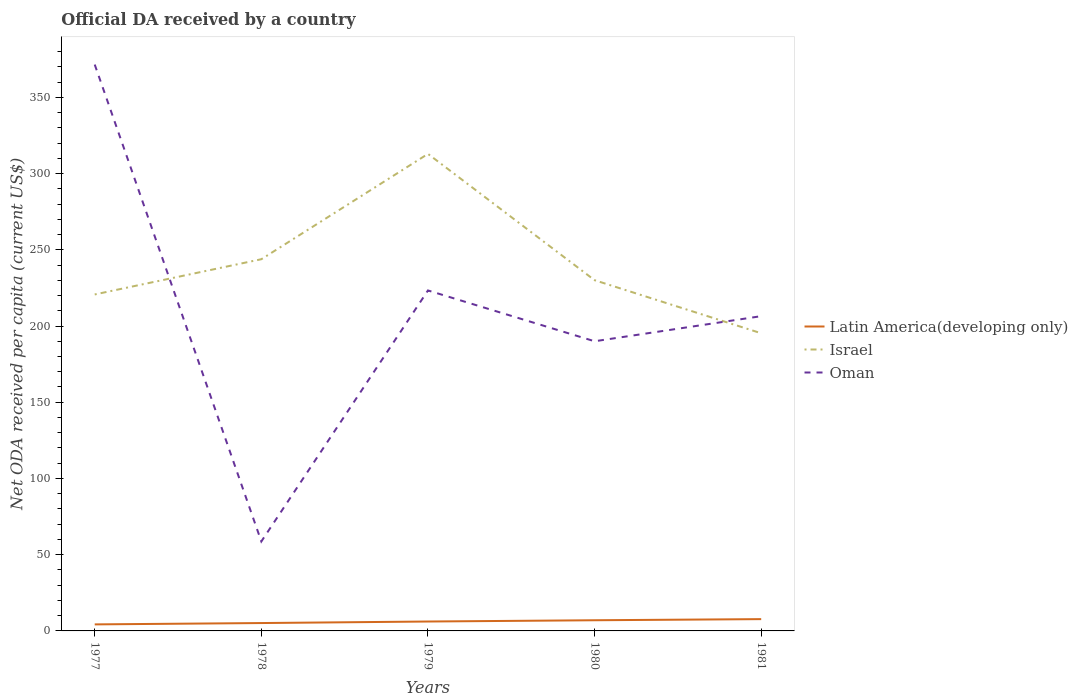How many different coloured lines are there?
Ensure brevity in your answer.  3. Across all years, what is the maximum ODA received in in Latin America(developing only)?
Provide a short and direct response. 4.28. In which year was the ODA received in in Latin America(developing only) maximum?
Your answer should be compact. 1977. What is the total ODA received in in Israel in the graph?
Keep it short and to the point. 13.76. What is the difference between the highest and the second highest ODA received in in Israel?
Provide a succinct answer. 117.66. What is the difference between the highest and the lowest ODA received in in Oman?
Make the answer very short. 2. Is the ODA received in in Oman strictly greater than the ODA received in in Latin America(developing only) over the years?
Make the answer very short. No. How many lines are there?
Make the answer very short. 3. How many years are there in the graph?
Offer a very short reply. 5. Does the graph contain any zero values?
Give a very brief answer. No. How many legend labels are there?
Keep it short and to the point. 3. What is the title of the graph?
Provide a succinct answer. Official DA received by a country. What is the label or title of the Y-axis?
Provide a short and direct response. Net ODA received per capita (current US$). What is the Net ODA received per capita (current US$) of Latin America(developing only) in 1977?
Offer a terse response. 4.28. What is the Net ODA received per capita (current US$) in Israel in 1977?
Provide a succinct answer. 220.7. What is the Net ODA received per capita (current US$) in Oman in 1977?
Provide a short and direct response. 371.49. What is the Net ODA received per capita (current US$) in Latin America(developing only) in 1978?
Offer a very short reply. 5.17. What is the Net ODA received per capita (current US$) in Israel in 1978?
Ensure brevity in your answer.  243.81. What is the Net ODA received per capita (current US$) in Oman in 1978?
Provide a short and direct response. 58.69. What is the Net ODA received per capita (current US$) in Latin America(developing only) in 1979?
Keep it short and to the point. 6.17. What is the Net ODA received per capita (current US$) of Israel in 1979?
Your response must be concise. 312.91. What is the Net ODA received per capita (current US$) of Oman in 1979?
Make the answer very short. 223.33. What is the Net ODA received per capita (current US$) in Latin America(developing only) in 1980?
Offer a terse response. 7. What is the Net ODA received per capita (current US$) in Israel in 1980?
Your answer should be very brief. 230.06. What is the Net ODA received per capita (current US$) of Oman in 1980?
Provide a succinct answer. 190. What is the Net ODA received per capita (current US$) in Latin America(developing only) in 1981?
Offer a very short reply. 7.73. What is the Net ODA received per capita (current US$) in Israel in 1981?
Your response must be concise. 195.25. What is the Net ODA received per capita (current US$) in Oman in 1981?
Your response must be concise. 206.46. Across all years, what is the maximum Net ODA received per capita (current US$) of Latin America(developing only)?
Give a very brief answer. 7.73. Across all years, what is the maximum Net ODA received per capita (current US$) in Israel?
Provide a succinct answer. 312.91. Across all years, what is the maximum Net ODA received per capita (current US$) of Oman?
Keep it short and to the point. 371.49. Across all years, what is the minimum Net ODA received per capita (current US$) in Latin America(developing only)?
Keep it short and to the point. 4.28. Across all years, what is the minimum Net ODA received per capita (current US$) in Israel?
Offer a very short reply. 195.25. Across all years, what is the minimum Net ODA received per capita (current US$) of Oman?
Offer a very short reply. 58.69. What is the total Net ODA received per capita (current US$) in Latin America(developing only) in the graph?
Give a very brief answer. 30.35. What is the total Net ODA received per capita (current US$) in Israel in the graph?
Offer a terse response. 1202.73. What is the total Net ODA received per capita (current US$) of Oman in the graph?
Offer a terse response. 1049.98. What is the difference between the Net ODA received per capita (current US$) in Latin America(developing only) in 1977 and that in 1978?
Give a very brief answer. -0.89. What is the difference between the Net ODA received per capita (current US$) of Israel in 1977 and that in 1978?
Give a very brief answer. -23.11. What is the difference between the Net ODA received per capita (current US$) in Oman in 1977 and that in 1978?
Offer a terse response. 312.8. What is the difference between the Net ODA received per capita (current US$) in Latin America(developing only) in 1977 and that in 1979?
Provide a succinct answer. -1.89. What is the difference between the Net ODA received per capita (current US$) in Israel in 1977 and that in 1979?
Give a very brief answer. -92.21. What is the difference between the Net ODA received per capita (current US$) in Oman in 1977 and that in 1979?
Keep it short and to the point. 148.17. What is the difference between the Net ODA received per capita (current US$) in Latin America(developing only) in 1977 and that in 1980?
Keep it short and to the point. -2.72. What is the difference between the Net ODA received per capita (current US$) in Israel in 1977 and that in 1980?
Your response must be concise. -9.35. What is the difference between the Net ODA received per capita (current US$) in Oman in 1977 and that in 1980?
Ensure brevity in your answer.  181.5. What is the difference between the Net ODA received per capita (current US$) in Latin America(developing only) in 1977 and that in 1981?
Make the answer very short. -3.45. What is the difference between the Net ODA received per capita (current US$) of Israel in 1977 and that in 1981?
Offer a terse response. 25.45. What is the difference between the Net ODA received per capita (current US$) of Oman in 1977 and that in 1981?
Your response must be concise. 165.03. What is the difference between the Net ODA received per capita (current US$) of Latin America(developing only) in 1978 and that in 1979?
Keep it short and to the point. -1. What is the difference between the Net ODA received per capita (current US$) in Israel in 1978 and that in 1979?
Offer a very short reply. -69.1. What is the difference between the Net ODA received per capita (current US$) in Oman in 1978 and that in 1979?
Offer a very short reply. -164.63. What is the difference between the Net ODA received per capita (current US$) of Latin America(developing only) in 1978 and that in 1980?
Ensure brevity in your answer.  -1.83. What is the difference between the Net ODA received per capita (current US$) of Israel in 1978 and that in 1980?
Provide a short and direct response. 13.76. What is the difference between the Net ODA received per capita (current US$) in Oman in 1978 and that in 1980?
Ensure brevity in your answer.  -131.3. What is the difference between the Net ODA received per capita (current US$) of Latin America(developing only) in 1978 and that in 1981?
Offer a very short reply. -2.56. What is the difference between the Net ODA received per capita (current US$) of Israel in 1978 and that in 1981?
Give a very brief answer. 48.56. What is the difference between the Net ODA received per capita (current US$) in Oman in 1978 and that in 1981?
Offer a terse response. -147.77. What is the difference between the Net ODA received per capita (current US$) of Latin America(developing only) in 1979 and that in 1980?
Give a very brief answer. -0.83. What is the difference between the Net ODA received per capita (current US$) in Israel in 1979 and that in 1980?
Offer a very short reply. 82.85. What is the difference between the Net ODA received per capita (current US$) of Oman in 1979 and that in 1980?
Provide a succinct answer. 33.33. What is the difference between the Net ODA received per capita (current US$) of Latin America(developing only) in 1979 and that in 1981?
Your response must be concise. -1.56. What is the difference between the Net ODA received per capita (current US$) of Israel in 1979 and that in 1981?
Give a very brief answer. 117.66. What is the difference between the Net ODA received per capita (current US$) of Oman in 1979 and that in 1981?
Make the answer very short. 16.86. What is the difference between the Net ODA received per capita (current US$) in Latin America(developing only) in 1980 and that in 1981?
Give a very brief answer. -0.74. What is the difference between the Net ODA received per capita (current US$) of Israel in 1980 and that in 1981?
Ensure brevity in your answer.  34.81. What is the difference between the Net ODA received per capita (current US$) in Oman in 1980 and that in 1981?
Ensure brevity in your answer.  -16.47. What is the difference between the Net ODA received per capita (current US$) in Latin America(developing only) in 1977 and the Net ODA received per capita (current US$) in Israel in 1978?
Keep it short and to the point. -239.53. What is the difference between the Net ODA received per capita (current US$) in Latin America(developing only) in 1977 and the Net ODA received per capita (current US$) in Oman in 1978?
Offer a terse response. -54.42. What is the difference between the Net ODA received per capita (current US$) in Israel in 1977 and the Net ODA received per capita (current US$) in Oman in 1978?
Provide a succinct answer. 162.01. What is the difference between the Net ODA received per capita (current US$) of Latin America(developing only) in 1977 and the Net ODA received per capita (current US$) of Israel in 1979?
Ensure brevity in your answer.  -308.63. What is the difference between the Net ODA received per capita (current US$) in Latin America(developing only) in 1977 and the Net ODA received per capita (current US$) in Oman in 1979?
Ensure brevity in your answer.  -219.05. What is the difference between the Net ODA received per capita (current US$) of Israel in 1977 and the Net ODA received per capita (current US$) of Oman in 1979?
Keep it short and to the point. -2.62. What is the difference between the Net ODA received per capita (current US$) of Latin America(developing only) in 1977 and the Net ODA received per capita (current US$) of Israel in 1980?
Keep it short and to the point. -225.78. What is the difference between the Net ODA received per capita (current US$) of Latin America(developing only) in 1977 and the Net ODA received per capita (current US$) of Oman in 1980?
Ensure brevity in your answer.  -185.72. What is the difference between the Net ODA received per capita (current US$) of Israel in 1977 and the Net ODA received per capita (current US$) of Oman in 1980?
Make the answer very short. 30.7. What is the difference between the Net ODA received per capita (current US$) of Latin America(developing only) in 1977 and the Net ODA received per capita (current US$) of Israel in 1981?
Make the answer very short. -190.97. What is the difference between the Net ODA received per capita (current US$) in Latin America(developing only) in 1977 and the Net ODA received per capita (current US$) in Oman in 1981?
Keep it short and to the point. -202.19. What is the difference between the Net ODA received per capita (current US$) in Israel in 1977 and the Net ODA received per capita (current US$) in Oman in 1981?
Offer a very short reply. 14.24. What is the difference between the Net ODA received per capita (current US$) of Latin America(developing only) in 1978 and the Net ODA received per capita (current US$) of Israel in 1979?
Your response must be concise. -307.74. What is the difference between the Net ODA received per capita (current US$) in Latin America(developing only) in 1978 and the Net ODA received per capita (current US$) in Oman in 1979?
Make the answer very short. -218.16. What is the difference between the Net ODA received per capita (current US$) of Israel in 1978 and the Net ODA received per capita (current US$) of Oman in 1979?
Ensure brevity in your answer.  20.49. What is the difference between the Net ODA received per capita (current US$) of Latin America(developing only) in 1978 and the Net ODA received per capita (current US$) of Israel in 1980?
Offer a terse response. -224.89. What is the difference between the Net ODA received per capita (current US$) of Latin America(developing only) in 1978 and the Net ODA received per capita (current US$) of Oman in 1980?
Provide a short and direct response. -184.83. What is the difference between the Net ODA received per capita (current US$) of Israel in 1978 and the Net ODA received per capita (current US$) of Oman in 1980?
Your answer should be compact. 53.81. What is the difference between the Net ODA received per capita (current US$) of Latin America(developing only) in 1978 and the Net ODA received per capita (current US$) of Israel in 1981?
Make the answer very short. -190.08. What is the difference between the Net ODA received per capita (current US$) of Latin America(developing only) in 1978 and the Net ODA received per capita (current US$) of Oman in 1981?
Make the answer very short. -201.3. What is the difference between the Net ODA received per capita (current US$) in Israel in 1978 and the Net ODA received per capita (current US$) in Oman in 1981?
Make the answer very short. 37.35. What is the difference between the Net ODA received per capita (current US$) in Latin America(developing only) in 1979 and the Net ODA received per capita (current US$) in Israel in 1980?
Provide a short and direct response. -223.89. What is the difference between the Net ODA received per capita (current US$) in Latin America(developing only) in 1979 and the Net ODA received per capita (current US$) in Oman in 1980?
Offer a terse response. -183.83. What is the difference between the Net ODA received per capita (current US$) of Israel in 1979 and the Net ODA received per capita (current US$) of Oman in 1980?
Your answer should be very brief. 122.91. What is the difference between the Net ODA received per capita (current US$) of Latin America(developing only) in 1979 and the Net ODA received per capita (current US$) of Israel in 1981?
Offer a very short reply. -189.08. What is the difference between the Net ODA received per capita (current US$) of Latin America(developing only) in 1979 and the Net ODA received per capita (current US$) of Oman in 1981?
Give a very brief answer. -200.3. What is the difference between the Net ODA received per capita (current US$) in Israel in 1979 and the Net ODA received per capita (current US$) in Oman in 1981?
Offer a terse response. 106.45. What is the difference between the Net ODA received per capita (current US$) of Latin America(developing only) in 1980 and the Net ODA received per capita (current US$) of Israel in 1981?
Offer a very short reply. -188.25. What is the difference between the Net ODA received per capita (current US$) of Latin America(developing only) in 1980 and the Net ODA received per capita (current US$) of Oman in 1981?
Give a very brief answer. -199.47. What is the difference between the Net ODA received per capita (current US$) of Israel in 1980 and the Net ODA received per capita (current US$) of Oman in 1981?
Give a very brief answer. 23.59. What is the average Net ODA received per capita (current US$) of Latin America(developing only) per year?
Your response must be concise. 6.07. What is the average Net ODA received per capita (current US$) of Israel per year?
Your response must be concise. 240.55. What is the average Net ODA received per capita (current US$) of Oman per year?
Ensure brevity in your answer.  210. In the year 1977, what is the difference between the Net ODA received per capita (current US$) in Latin America(developing only) and Net ODA received per capita (current US$) in Israel?
Offer a terse response. -216.42. In the year 1977, what is the difference between the Net ODA received per capita (current US$) of Latin America(developing only) and Net ODA received per capita (current US$) of Oman?
Make the answer very short. -367.22. In the year 1977, what is the difference between the Net ODA received per capita (current US$) in Israel and Net ODA received per capita (current US$) in Oman?
Ensure brevity in your answer.  -150.79. In the year 1978, what is the difference between the Net ODA received per capita (current US$) in Latin America(developing only) and Net ODA received per capita (current US$) in Israel?
Provide a succinct answer. -238.64. In the year 1978, what is the difference between the Net ODA received per capita (current US$) of Latin America(developing only) and Net ODA received per capita (current US$) of Oman?
Your response must be concise. -53.53. In the year 1978, what is the difference between the Net ODA received per capita (current US$) in Israel and Net ODA received per capita (current US$) in Oman?
Make the answer very short. 185.12. In the year 1979, what is the difference between the Net ODA received per capita (current US$) of Latin America(developing only) and Net ODA received per capita (current US$) of Israel?
Your answer should be compact. -306.74. In the year 1979, what is the difference between the Net ODA received per capita (current US$) of Latin America(developing only) and Net ODA received per capita (current US$) of Oman?
Offer a very short reply. -217.16. In the year 1979, what is the difference between the Net ODA received per capita (current US$) of Israel and Net ODA received per capita (current US$) of Oman?
Your answer should be very brief. 89.58. In the year 1980, what is the difference between the Net ODA received per capita (current US$) in Latin America(developing only) and Net ODA received per capita (current US$) in Israel?
Your answer should be very brief. -223.06. In the year 1980, what is the difference between the Net ODA received per capita (current US$) in Latin America(developing only) and Net ODA received per capita (current US$) in Oman?
Your response must be concise. -183. In the year 1980, what is the difference between the Net ODA received per capita (current US$) of Israel and Net ODA received per capita (current US$) of Oman?
Provide a short and direct response. 40.06. In the year 1981, what is the difference between the Net ODA received per capita (current US$) of Latin America(developing only) and Net ODA received per capita (current US$) of Israel?
Make the answer very short. -187.52. In the year 1981, what is the difference between the Net ODA received per capita (current US$) of Latin America(developing only) and Net ODA received per capita (current US$) of Oman?
Give a very brief answer. -198.73. In the year 1981, what is the difference between the Net ODA received per capita (current US$) in Israel and Net ODA received per capita (current US$) in Oman?
Your response must be concise. -11.21. What is the ratio of the Net ODA received per capita (current US$) in Latin America(developing only) in 1977 to that in 1978?
Your response must be concise. 0.83. What is the ratio of the Net ODA received per capita (current US$) of Israel in 1977 to that in 1978?
Offer a terse response. 0.91. What is the ratio of the Net ODA received per capita (current US$) in Oman in 1977 to that in 1978?
Your response must be concise. 6.33. What is the ratio of the Net ODA received per capita (current US$) in Latin America(developing only) in 1977 to that in 1979?
Keep it short and to the point. 0.69. What is the ratio of the Net ODA received per capita (current US$) in Israel in 1977 to that in 1979?
Offer a very short reply. 0.71. What is the ratio of the Net ODA received per capita (current US$) of Oman in 1977 to that in 1979?
Your answer should be compact. 1.66. What is the ratio of the Net ODA received per capita (current US$) in Latin America(developing only) in 1977 to that in 1980?
Offer a terse response. 0.61. What is the ratio of the Net ODA received per capita (current US$) in Israel in 1977 to that in 1980?
Make the answer very short. 0.96. What is the ratio of the Net ODA received per capita (current US$) of Oman in 1977 to that in 1980?
Offer a very short reply. 1.96. What is the ratio of the Net ODA received per capita (current US$) in Latin America(developing only) in 1977 to that in 1981?
Ensure brevity in your answer.  0.55. What is the ratio of the Net ODA received per capita (current US$) of Israel in 1977 to that in 1981?
Provide a short and direct response. 1.13. What is the ratio of the Net ODA received per capita (current US$) of Oman in 1977 to that in 1981?
Provide a succinct answer. 1.8. What is the ratio of the Net ODA received per capita (current US$) in Latin America(developing only) in 1978 to that in 1979?
Keep it short and to the point. 0.84. What is the ratio of the Net ODA received per capita (current US$) in Israel in 1978 to that in 1979?
Provide a short and direct response. 0.78. What is the ratio of the Net ODA received per capita (current US$) of Oman in 1978 to that in 1979?
Your answer should be very brief. 0.26. What is the ratio of the Net ODA received per capita (current US$) of Latin America(developing only) in 1978 to that in 1980?
Make the answer very short. 0.74. What is the ratio of the Net ODA received per capita (current US$) of Israel in 1978 to that in 1980?
Ensure brevity in your answer.  1.06. What is the ratio of the Net ODA received per capita (current US$) of Oman in 1978 to that in 1980?
Keep it short and to the point. 0.31. What is the ratio of the Net ODA received per capita (current US$) of Latin America(developing only) in 1978 to that in 1981?
Your answer should be very brief. 0.67. What is the ratio of the Net ODA received per capita (current US$) in Israel in 1978 to that in 1981?
Ensure brevity in your answer.  1.25. What is the ratio of the Net ODA received per capita (current US$) of Oman in 1978 to that in 1981?
Give a very brief answer. 0.28. What is the ratio of the Net ODA received per capita (current US$) in Latin America(developing only) in 1979 to that in 1980?
Offer a very short reply. 0.88. What is the ratio of the Net ODA received per capita (current US$) in Israel in 1979 to that in 1980?
Provide a short and direct response. 1.36. What is the ratio of the Net ODA received per capita (current US$) in Oman in 1979 to that in 1980?
Keep it short and to the point. 1.18. What is the ratio of the Net ODA received per capita (current US$) in Latin America(developing only) in 1979 to that in 1981?
Provide a short and direct response. 0.8. What is the ratio of the Net ODA received per capita (current US$) of Israel in 1979 to that in 1981?
Offer a very short reply. 1.6. What is the ratio of the Net ODA received per capita (current US$) in Oman in 1979 to that in 1981?
Your response must be concise. 1.08. What is the ratio of the Net ODA received per capita (current US$) of Latin America(developing only) in 1980 to that in 1981?
Your answer should be compact. 0.9. What is the ratio of the Net ODA received per capita (current US$) of Israel in 1980 to that in 1981?
Provide a succinct answer. 1.18. What is the ratio of the Net ODA received per capita (current US$) in Oman in 1980 to that in 1981?
Your answer should be compact. 0.92. What is the difference between the highest and the second highest Net ODA received per capita (current US$) in Latin America(developing only)?
Offer a very short reply. 0.74. What is the difference between the highest and the second highest Net ODA received per capita (current US$) of Israel?
Provide a succinct answer. 69.1. What is the difference between the highest and the second highest Net ODA received per capita (current US$) in Oman?
Provide a short and direct response. 148.17. What is the difference between the highest and the lowest Net ODA received per capita (current US$) in Latin America(developing only)?
Ensure brevity in your answer.  3.45. What is the difference between the highest and the lowest Net ODA received per capita (current US$) of Israel?
Your answer should be very brief. 117.66. What is the difference between the highest and the lowest Net ODA received per capita (current US$) of Oman?
Keep it short and to the point. 312.8. 